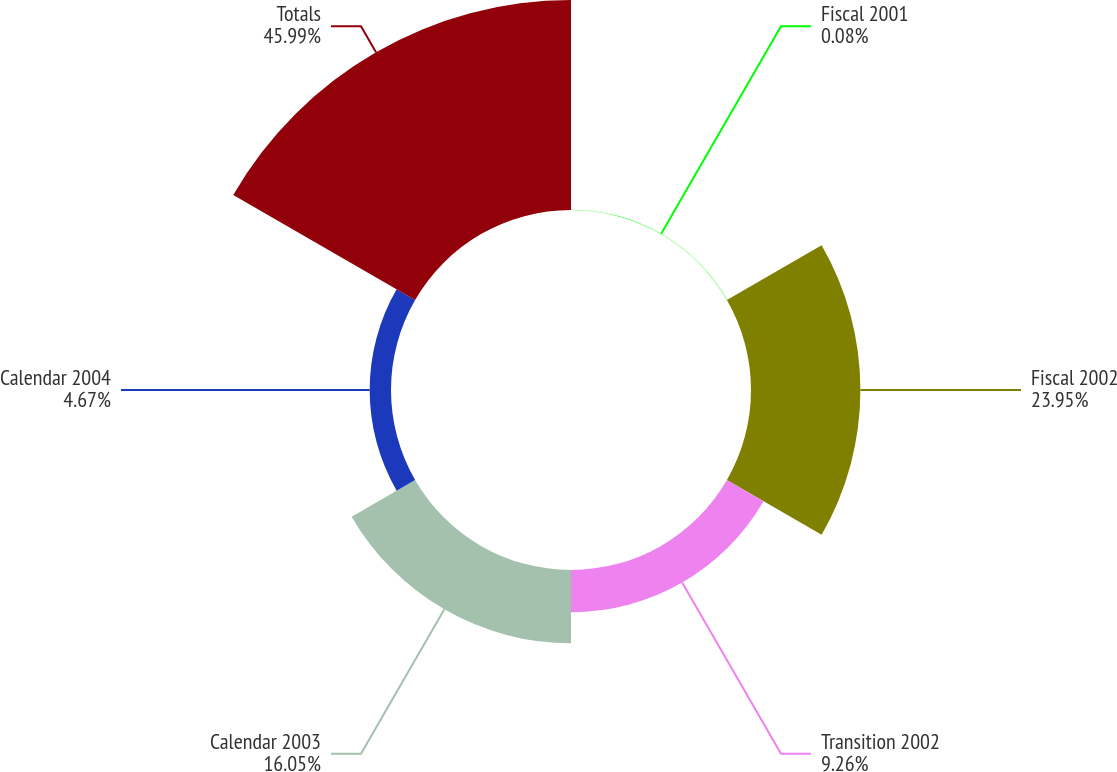<chart> <loc_0><loc_0><loc_500><loc_500><pie_chart><fcel>Fiscal 2001<fcel>Fiscal 2002<fcel>Transition 2002<fcel>Calendar 2003<fcel>Calendar 2004<fcel>Totals<nl><fcel>0.08%<fcel>23.95%<fcel>9.26%<fcel>16.05%<fcel>4.67%<fcel>45.98%<nl></chart> 